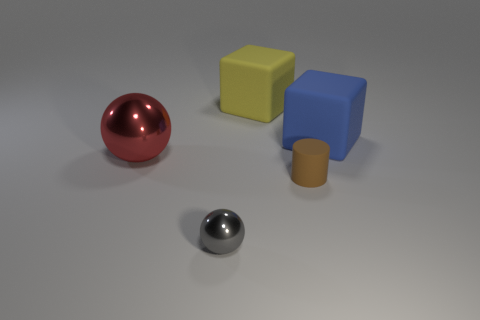Subtract all blue blocks. How many blocks are left? 1 Add 2 blue objects. How many objects exist? 7 Subtract all cyan spheres. How many purple cylinders are left? 0 Add 1 metal spheres. How many metal spheres exist? 3 Subtract 0 red cubes. How many objects are left? 5 Subtract all cubes. How many objects are left? 3 Subtract all cyan blocks. Subtract all cyan cylinders. How many blocks are left? 2 Subtract all blue matte cubes. Subtract all gray shiny spheres. How many objects are left? 3 Add 5 large red shiny balls. How many large red shiny balls are left? 6 